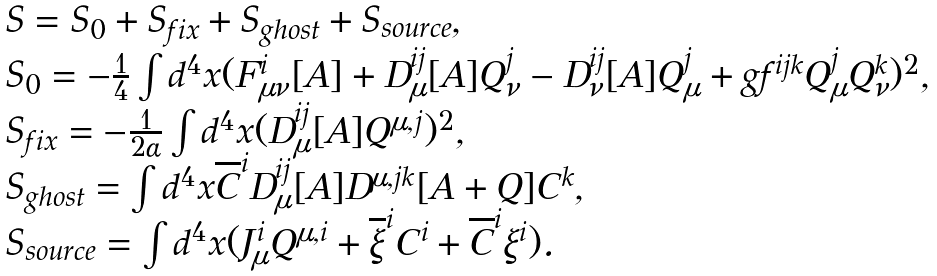<formula> <loc_0><loc_0><loc_500><loc_500>\begin{array} { l } { { S = S _ { 0 } + S _ { f i x } + S _ { g h o s t } + S _ { s o u r c e } , } } \\ { { S _ { 0 } = - \frac { 1 } { 4 } \int d ^ { 4 } x ( F _ { \mu \nu } ^ { i } [ A ] + D _ { \mu } ^ { i j } [ A ] Q _ { \nu } ^ { j } - D _ { \nu } ^ { i j } [ A ] Q _ { \mu } ^ { j } + g f ^ { i j k } Q _ { \mu } ^ { j } Q _ { \nu } ^ { k } ) ^ { 2 } , } } \\ { { S _ { f i x } = - \frac { 1 } { 2 \alpha } \int d ^ { 4 } x ( D _ { \mu } ^ { i j } [ A ] Q ^ { \mu , j } ) ^ { 2 } , } } \\ { { S _ { g h o s t } = \int d ^ { 4 } x \overline { C } ^ { i } D _ { \mu } ^ { i j } [ A ] D ^ { \mu , j k } [ A + Q ] C ^ { k } , } } \\ { { S _ { s o u r c e } = \int d ^ { 4 } x ( J _ { \mu } ^ { i } Q ^ { \mu , i } + \overline { \xi } ^ { i } C ^ { i } + \overline { C } ^ { i } \xi ^ { i } ) . } } \end{array}</formula> 